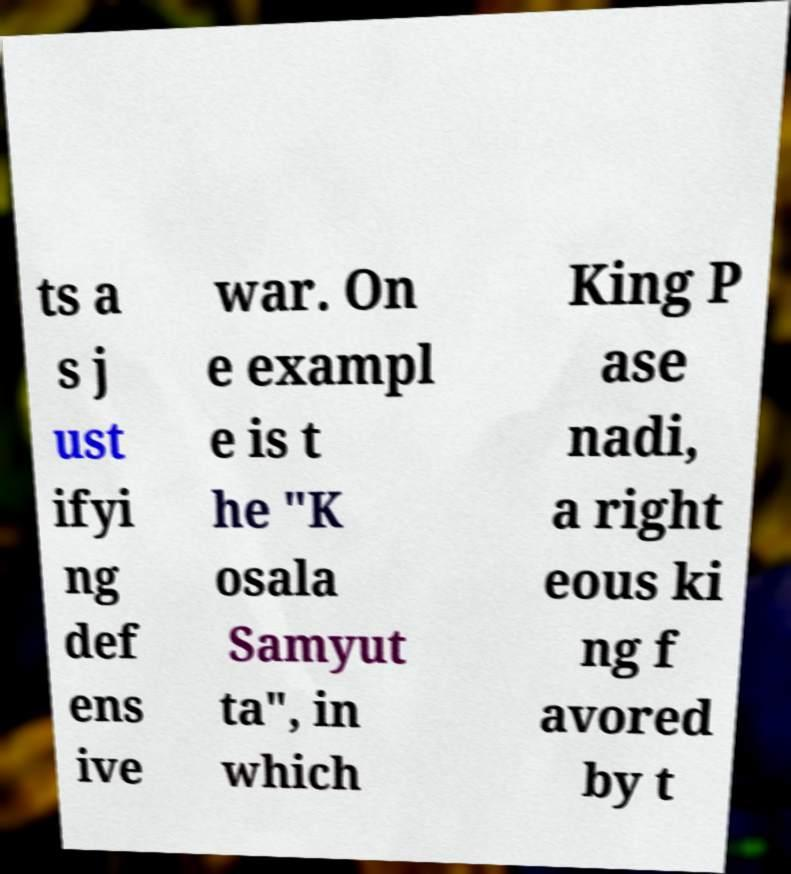Please read and relay the text visible in this image. What does it say? ts a s j ust ifyi ng def ens ive war. On e exampl e is t he "K osala Samyut ta", in which King P ase nadi, a right eous ki ng f avored by t 